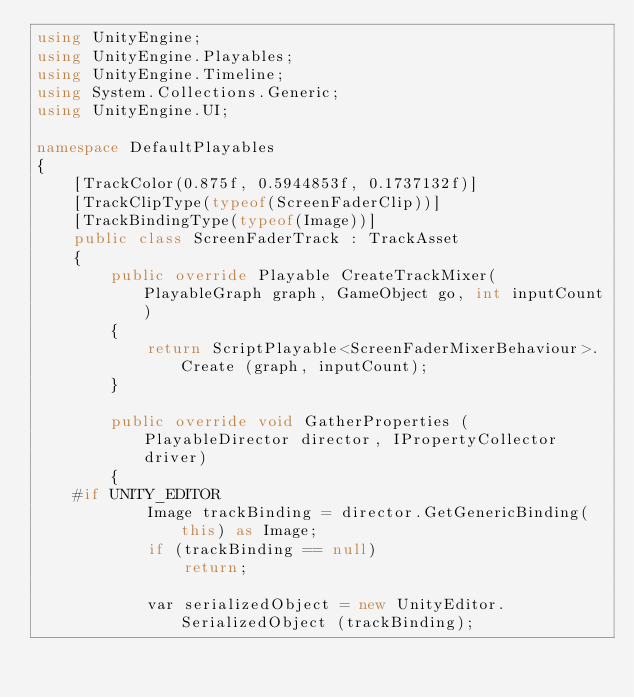Convert code to text. <code><loc_0><loc_0><loc_500><loc_500><_C#_>using UnityEngine;
using UnityEngine.Playables;
using UnityEngine.Timeline;
using System.Collections.Generic;
using UnityEngine.UI;

namespace DefaultPlayables
{
	[TrackColor(0.875f, 0.5944853f, 0.1737132f)]
	[TrackClipType(typeof(ScreenFaderClip))]
	[TrackBindingType(typeof(Image))]
	public class ScreenFaderTrack : TrackAsset
	{
	    public override Playable CreateTrackMixer(PlayableGraph graph, GameObject go, int inputCount)
	    {
	        return ScriptPlayable<ScreenFaderMixerBehaviour>.Create (graph, inputCount);
	    }

	    public override void GatherProperties (PlayableDirector director, IPropertyCollector driver)
	    {
	#if UNITY_EDITOR
	        Image trackBinding = director.GetGenericBinding(this) as Image;
	        if (trackBinding == null)
	            return;

	        var serializedObject = new UnityEditor.SerializedObject (trackBinding);</code> 